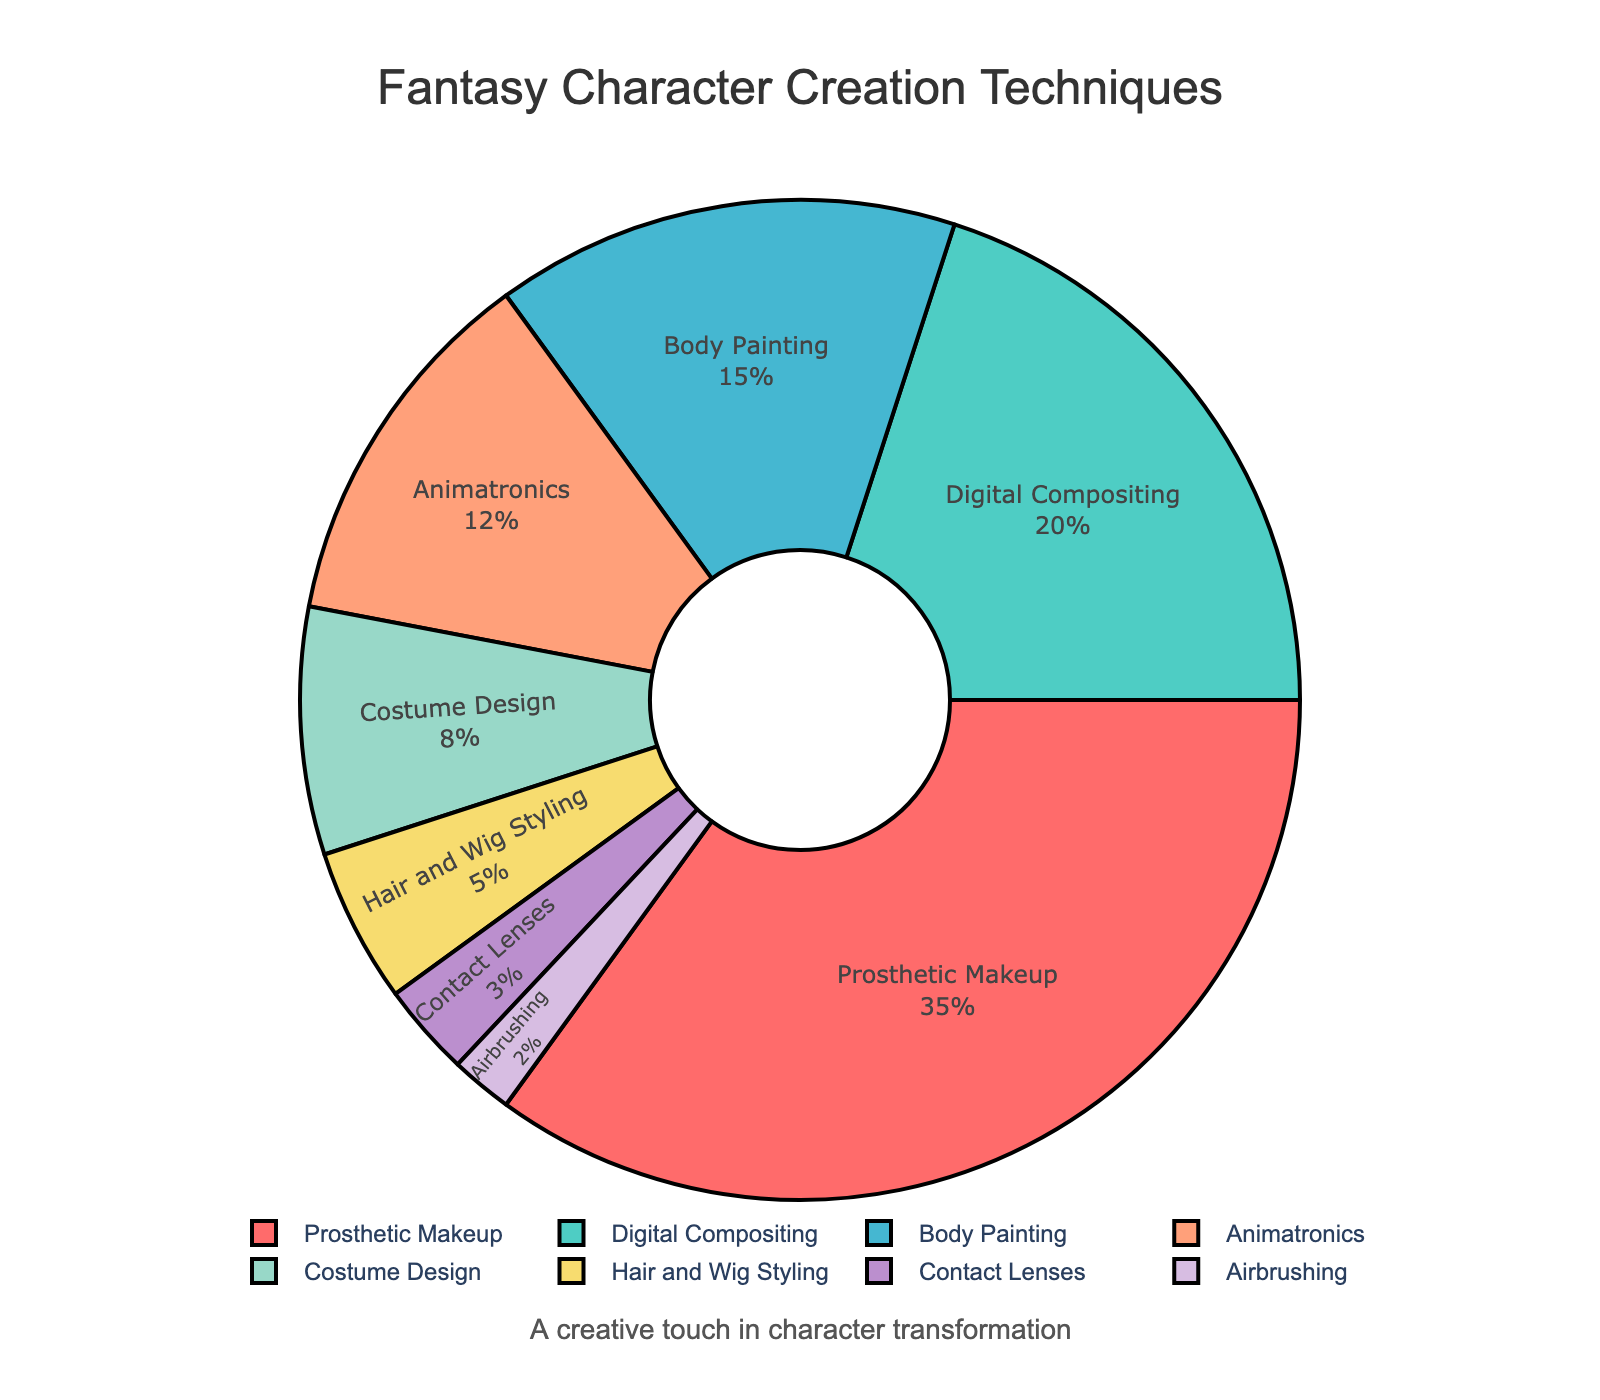What percentage of techniques involve physical transformation (Prosthetic Makeup, Body Painting, Costume Design, Hair and Wig Styling, Contact Lenses, Airbrushing)? Sum up the percentages of all techniques involving physical transformation. Adding them gives 35% (Prosthetic Makeup) + 15% (Body Painting) + 8% (Costume Design) + 5% (Hair and Wig Styling) + 3% (Contact Lenses) + 2% (Airbrushing) = 68%.
Answer: 68% Which technique is used the most in fantasy character creation? Identify the largest percentage figure. Prosthetic Makeup has the highest percentage at 35%.
Answer: Prosthetic Makeup What is the difference in percentage between Animatronics and Digital Compositing? Subtract the percentage of Animatronics from Digital Compositing. 20% (Digital Compositing) - 12% (Animatronics) = 8%.
Answer: 8% How does the percentage of Body Painting compare to that of Costume Design? Compare the two percentages directly. Body Painting (15%) is greater than Costume Design (8%).
Answer: Body Painting > Costume Design Which technique uses the smallest proportion? Identify the lowest percentage on the pie chart. Airbrushing has the lowest percentage at 2%.
Answer: Airbrushing Are the combined percentages of Prosthetic Makeup and Digital Compositing more or less than half the total? Sum the percentages of Prosthetic Makeup and Digital Compositing and compare to 50%. 35% (Prosthetic Makeup) + 20% (Digital Compositing) = 55%, which is more than half the total (50%).
Answer: More What proportion of techniques involve digital methods (Digital Compositing)? Identify the percentage of Digital Compositing directly from the chart. The percentage is 20%.
Answer: 20% Between Prosthetic Makeup, Body Painting, and Hair and Wig Styling, which has the second highest percentage? Compare percentages of the three techniques and find the middle value. Prosthetic Makeup (35%), Body Painting (15%), Hair and Wig Styling (5%). Body Painting is the second highest.
Answer: Body Painting How much more commonly is Prosthetic Makeup used compared to Animatronics? Subtract the percentage of Animatronics from that of Prosthetic Makeup. 35% (Prosthetic Makeup) - 12% (Animatronics) = 23%.
Answer: 23% If you combine the percentages of Costume Design and Hair and Wig Styling, do they together exceed Body Painting? Sum the percentages of Costume Design and Hair and Wig Styling and compare it to Body Painting. 8% (Costume Design) + 5% (Hair and Wig Styling) = 13%, which does not exceed 15% (Body Painting).
Answer: No 